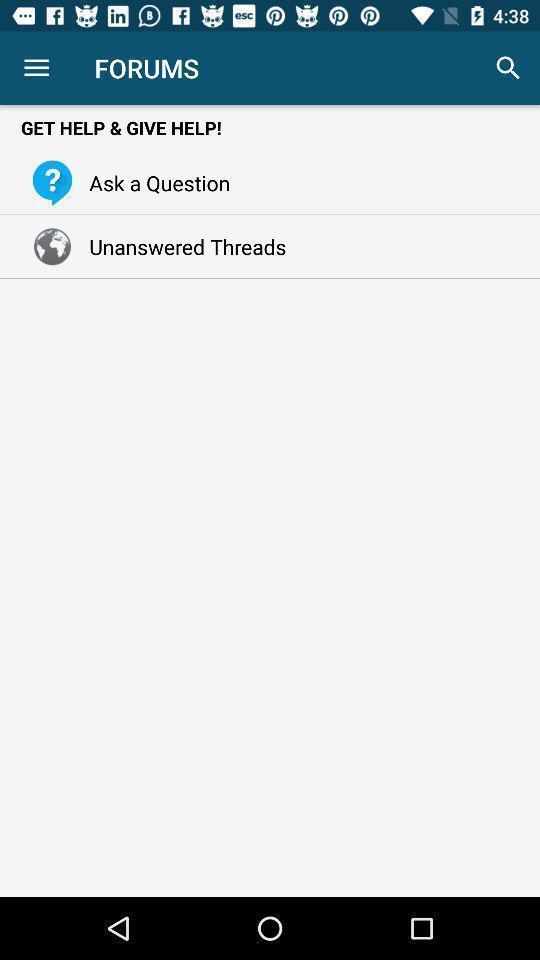Describe this image in words. Page showing get help and give help. 